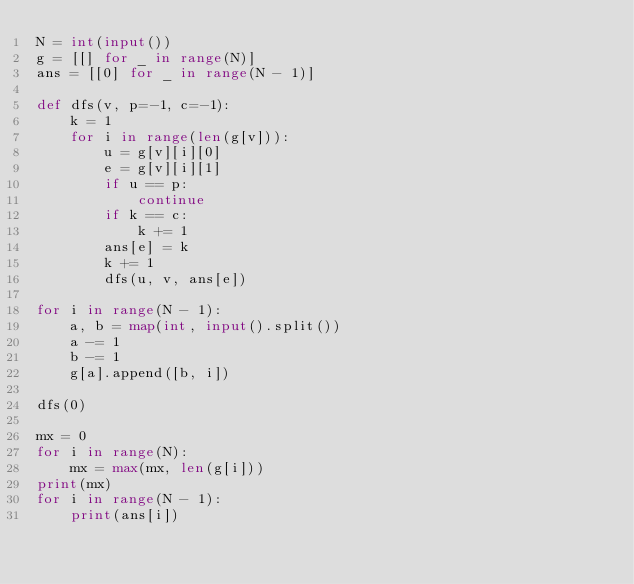Convert code to text. <code><loc_0><loc_0><loc_500><loc_500><_Python_>N = int(input())
g = [[] for _ in range(N)]
ans = [[0] for _ in range(N - 1)]

def dfs(v, p=-1, c=-1):
    k = 1
    for i in range(len(g[v])):
        u = g[v][i][0]
        e = g[v][i][1]
        if u == p:
            continue
        if k == c:
            k += 1
        ans[e] = k
        k += 1
        dfs(u, v, ans[e])

for i in range(N - 1):
    a, b = map(int, input().split())
    a -= 1
    b -= 1
    g[a].append([b, i])

dfs(0)

mx = 0
for i in range(N):
    mx = max(mx, len(g[i]))
print(mx)
for i in range(N - 1):
    print(ans[i])
</code> 